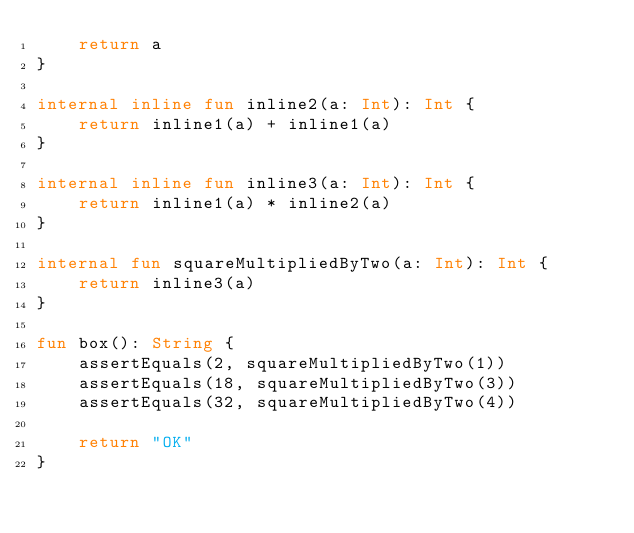<code> <loc_0><loc_0><loc_500><loc_500><_Kotlin_>    return a
}

internal inline fun inline2(a: Int): Int {
    return inline1(a) + inline1(a)
}

internal inline fun inline3(a: Int): Int {
    return inline1(a) * inline2(a)
}

internal fun squareMultipliedByTwo(a: Int): Int {
    return inline3(a)
}

fun box(): String {
    assertEquals(2, squareMultipliedByTwo(1))
    assertEquals(18, squareMultipliedByTwo(3))
    assertEquals(32, squareMultipliedByTwo(4))

    return "OK"
}</code> 